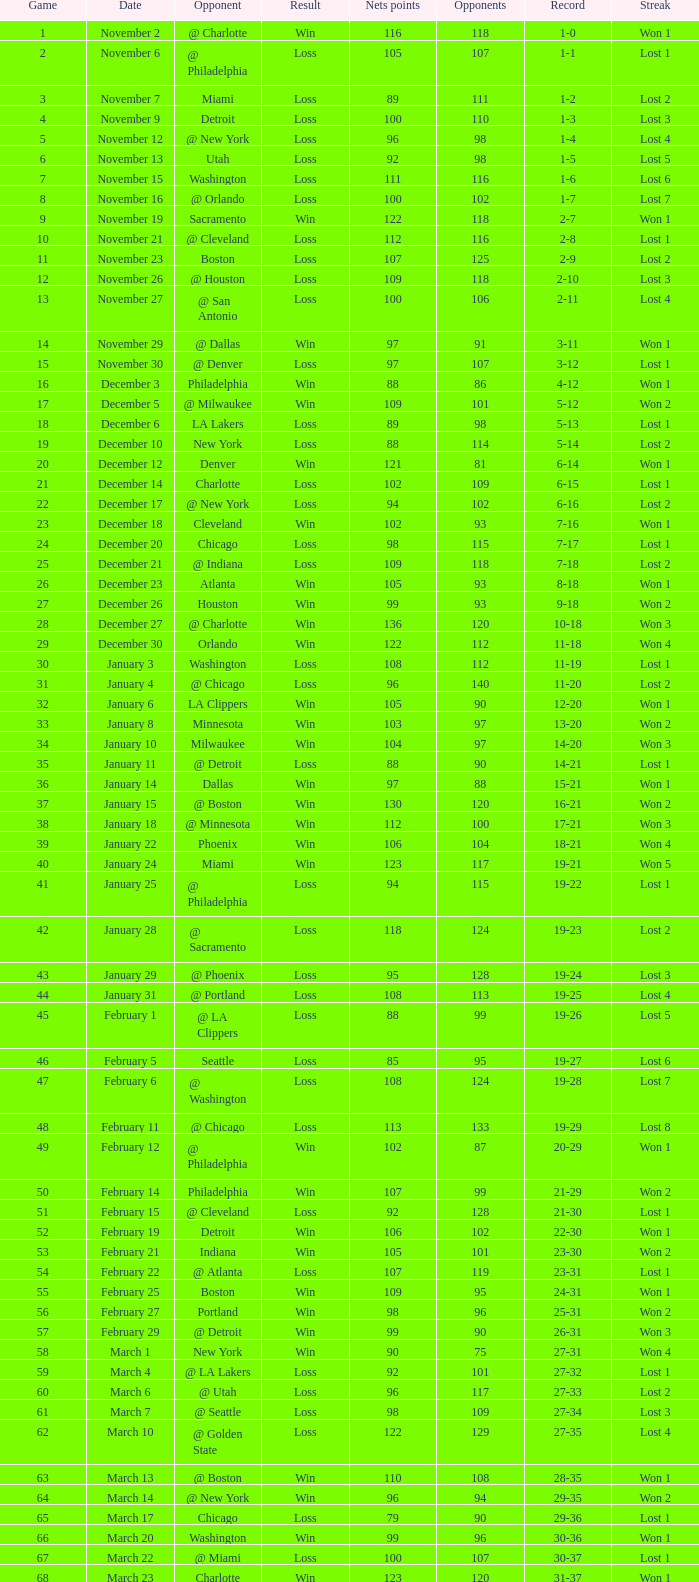What was the number of opponents in a game with over 20 participants on january 28? 124.0. 